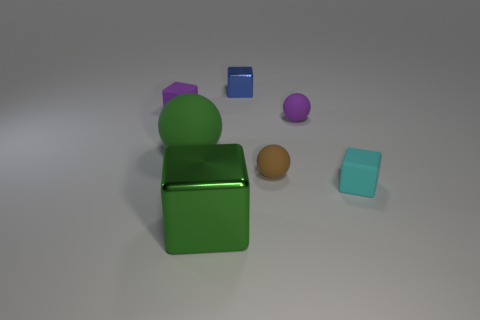Add 1 tiny rubber spheres. How many objects exist? 8 Subtract all cubes. How many objects are left? 3 Subtract 0 yellow cylinders. How many objects are left? 7 Subtract all small green matte objects. Subtract all blue blocks. How many objects are left? 6 Add 5 blue metallic objects. How many blue metallic objects are left? 6 Add 6 purple things. How many purple things exist? 8 